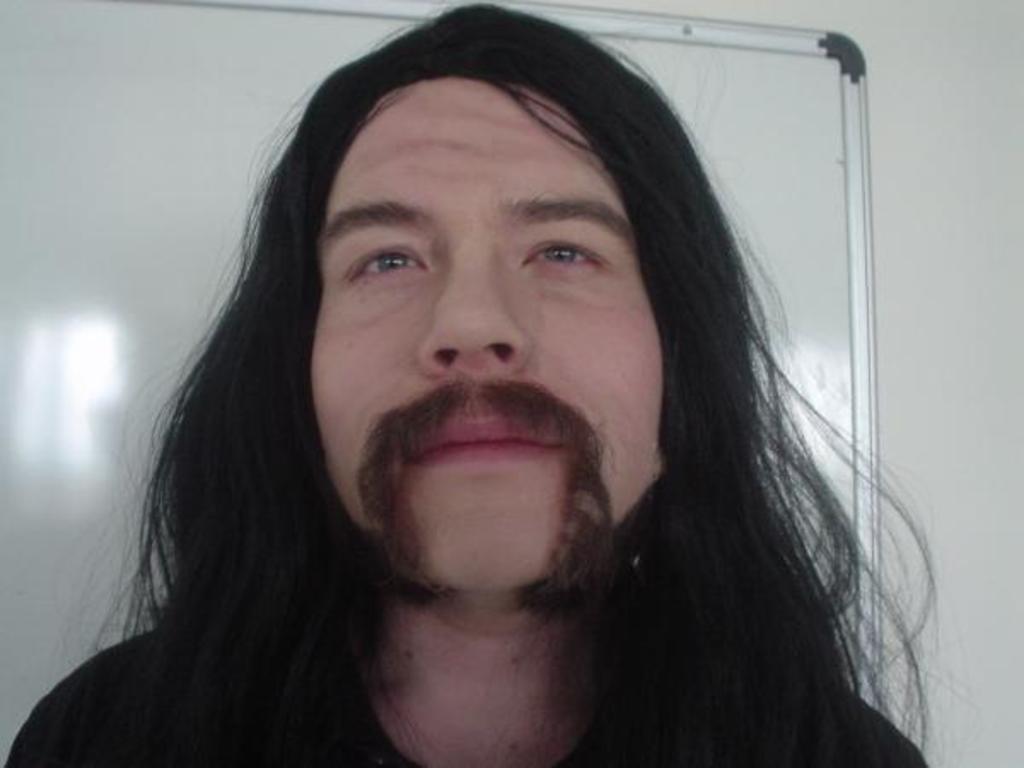Can you describe this image briefly? In the picture I can see a man with long hair. In the background, I can see the whiteboard on the wall. 